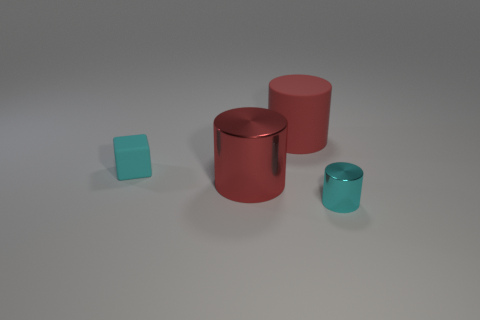Is the number of cyan matte cubes greater than the number of large yellow matte objects?
Provide a short and direct response. Yes. Does the metal cylinder behind the small cyan shiny thing have the same color as the large matte object?
Your answer should be very brief. Yes. What is the color of the small cube?
Make the answer very short. Cyan. Is there a red cylinder on the right side of the tiny object that is to the left of the tiny cylinder?
Ensure brevity in your answer.  Yes. There is a small cyan thing on the left side of the metal object to the right of the large rubber thing; what shape is it?
Your response must be concise. Cube. Are there fewer small shiny objects than metal things?
Your answer should be very brief. Yes. The thing that is to the right of the big metallic cylinder and behind the red metallic thing is what color?
Give a very brief answer. Red. Are there any cyan balls of the same size as the matte block?
Keep it short and to the point. No. What is the size of the metallic thing that is to the right of the matte object to the right of the small cyan rubber object?
Offer a very short reply. Small. Is the number of tiny things that are left of the red rubber object less than the number of tiny cylinders?
Make the answer very short. No. 